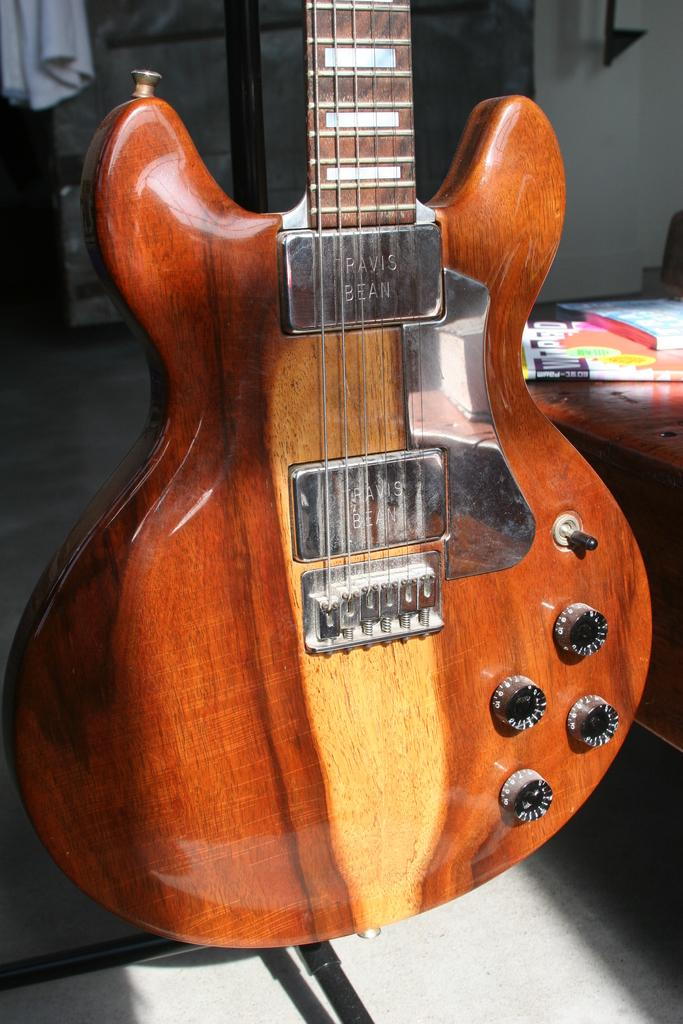What musical instrument is present in the image? There is a guitar in the image. How many ants are crawling on the guitar in the image? There are no ants present in the image; it only features a guitar. What is the name of the person playing the guitar in the image? There is no person playing the guitar in the image, so it is not possible to determine their name. 